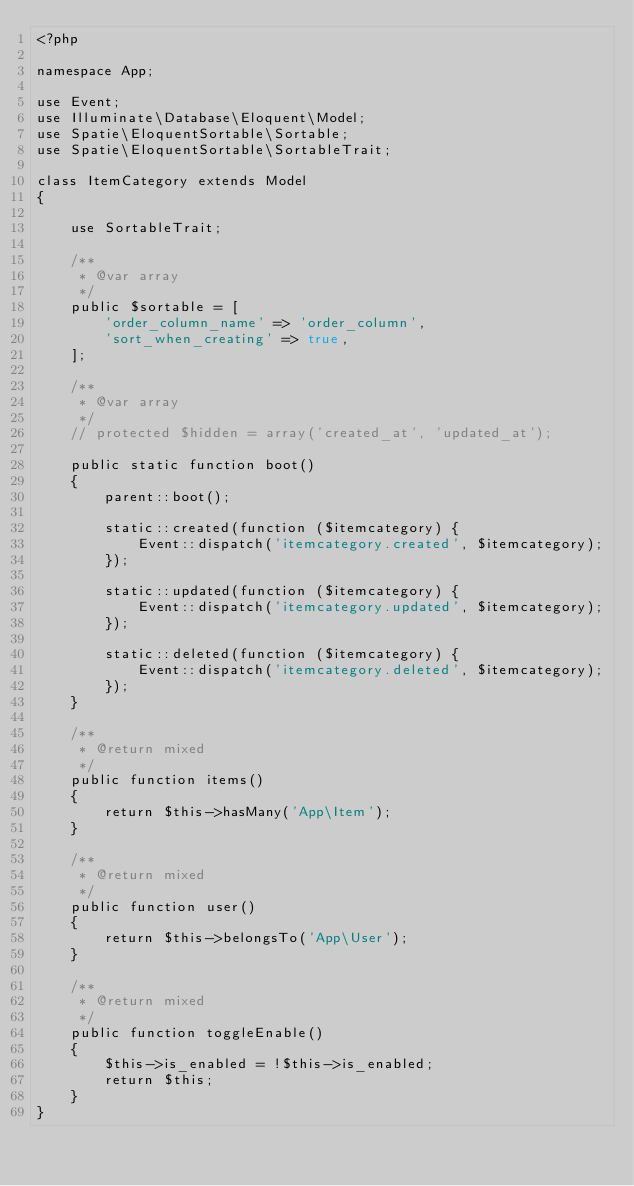<code> <loc_0><loc_0><loc_500><loc_500><_PHP_><?php

namespace App;

use Event;
use Illuminate\Database\Eloquent\Model;
use Spatie\EloquentSortable\Sortable;
use Spatie\EloquentSortable\SortableTrait;

class ItemCategory extends Model
{

    use SortableTrait;

    /**
     * @var array
     */
    public $sortable = [
        'order_column_name' => 'order_column',
        'sort_when_creating' => true,
    ];

    /**
     * @var array
     */
    // protected $hidden = array('created_at', 'updated_at');

    public static function boot()
    {
        parent::boot();

        static::created(function ($itemcategory) {
            Event::dispatch('itemcategory.created', $itemcategory);
        });

        static::updated(function ($itemcategory) {
            Event::dispatch('itemcategory.updated', $itemcategory);
        });

        static::deleted(function ($itemcategory) {
            Event::dispatch('itemcategory.deleted', $itemcategory);
        });
    }

    /**
     * @return mixed
     */
    public function items()
    {
        return $this->hasMany('App\Item');
    }

    /**
     * @return mixed
     */
    public function user()
    {
        return $this->belongsTo('App\User');
    }

    /**
     * @return mixed
     */
    public function toggleEnable()
    {
        $this->is_enabled = !$this->is_enabled;
        return $this;
    }
}
</code> 